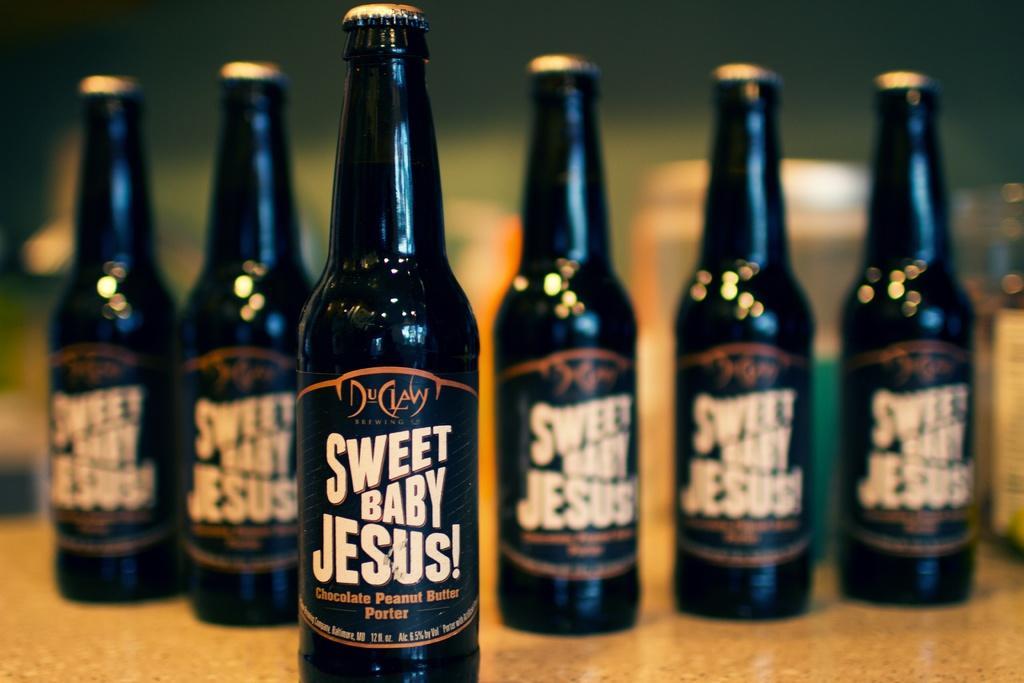In one or two sentences, can you explain what this image depicts? In the foreground of the picture there is a bottle. The background is blurred. In the background there are bottles. 